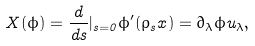Convert formula to latex. <formula><loc_0><loc_0><loc_500><loc_500>X ( \phi ) = \frac { d } { d s } | _ { s = 0 } \phi ^ { \prime } ( \rho _ { s } x ) = \partial _ { \lambda } \phi u _ { \lambda } ,</formula> 